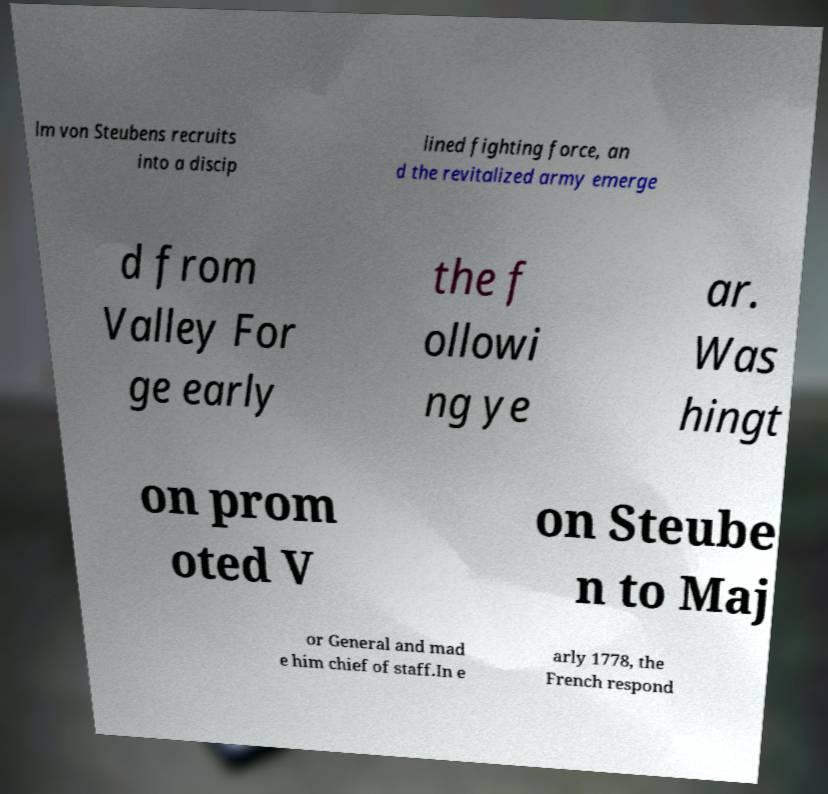Please identify and transcribe the text found in this image. lm von Steubens recruits into a discip lined fighting force, an d the revitalized army emerge d from Valley For ge early the f ollowi ng ye ar. Was hingt on prom oted V on Steube n to Maj or General and mad e him chief of staff.In e arly 1778, the French respond 